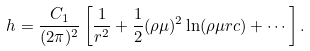Convert formula to latex. <formula><loc_0><loc_0><loc_500><loc_500>h = \frac { C _ { 1 } } { ( 2 \pi ) ^ { 2 } } \left [ \frac { 1 } { r ^ { 2 } } + \frac { 1 } { 2 } ( \rho \mu ) ^ { 2 } \ln ( \rho \mu r c ) + \cdots \right ] .</formula> 